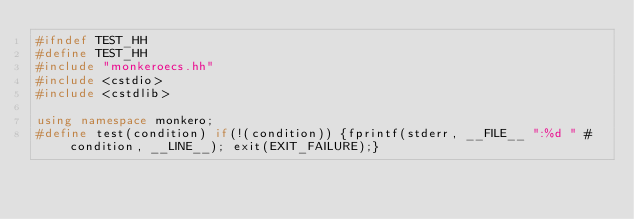<code> <loc_0><loc_0><loc_500><loc_500><_C++_>#ifndef TEST_HH
#define TEST_HH
#include "monkeroecs.hh"
#include <cstdio>
#include <cstdlib>

using namespace monkero;
#define test(condition) if(!(condition)) {fprintf(stderr, __FILE__ ":%d " #condition, __LINE__); exit(EXIT_FAILURE);}</code> 